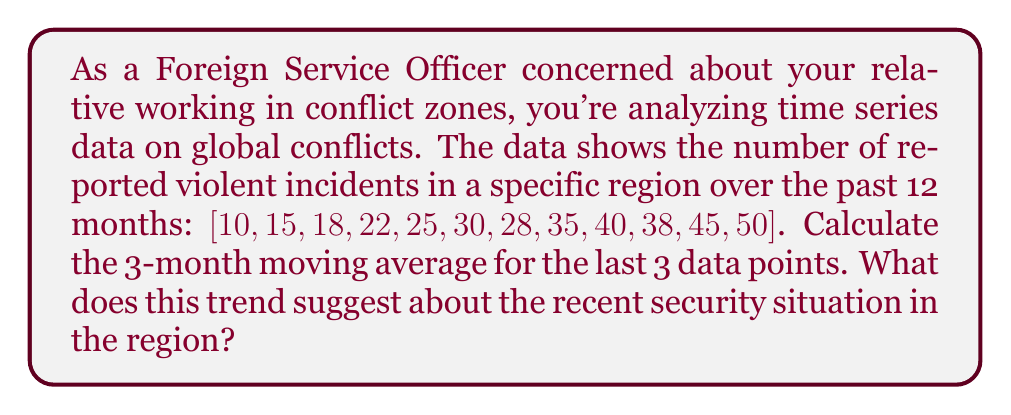What is the answer to this math problem? To calculate the 3-month moving average for the last 3 data points, we'll follow these steps:

1. Identify the last 3 data points: 38, 45, 50

2. Calculate the average for these 3 points:
   $$ \text{Average} = \frac{38 + 45 + 50}{3} = \frac{133}{3} = 44.33 $$

3. Identify the previous 3 data points: 35, 40, 38

4. Calculate the average for these 3 points:
   $$ \text{Average} = \frac{35 + 40 + 38}{3} = \frac{113}{3} = 37.67 $$

5. Identify the 3 data points before that: 28, 35, 40

6. Calculate the average for these 3 points:
   $$ \text{Average} = \frac{28 + 35 + 40}{3} = \frac{103}{3} = 34.33 $$

The 3-month moving averages for the last 3 data points are: 34.33, 37.67, and 44.33.

This trend suggests an increasing number of violent incidents in the region over the recent months. The moving average has increased from 34.33 to 37.67 to 44.33, indicating a consistent upward trend in the number of reported violent incidents. This suggests a deteriorating security situation in the region, which would be of significant concern for a Foreign Service Officer worried about a relative working in conflict zones.
Answer: 44.33, 37.67, 34.33; increasing trend indicates deteriorating security 